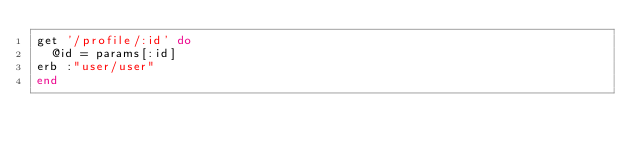Convert code to text. <code><loc_0><loc_0><loc_500><loc_500><_Ruby_>get '/profile/:id' do
  @id = params[:id]
erb :"user/user"
end


</code> 